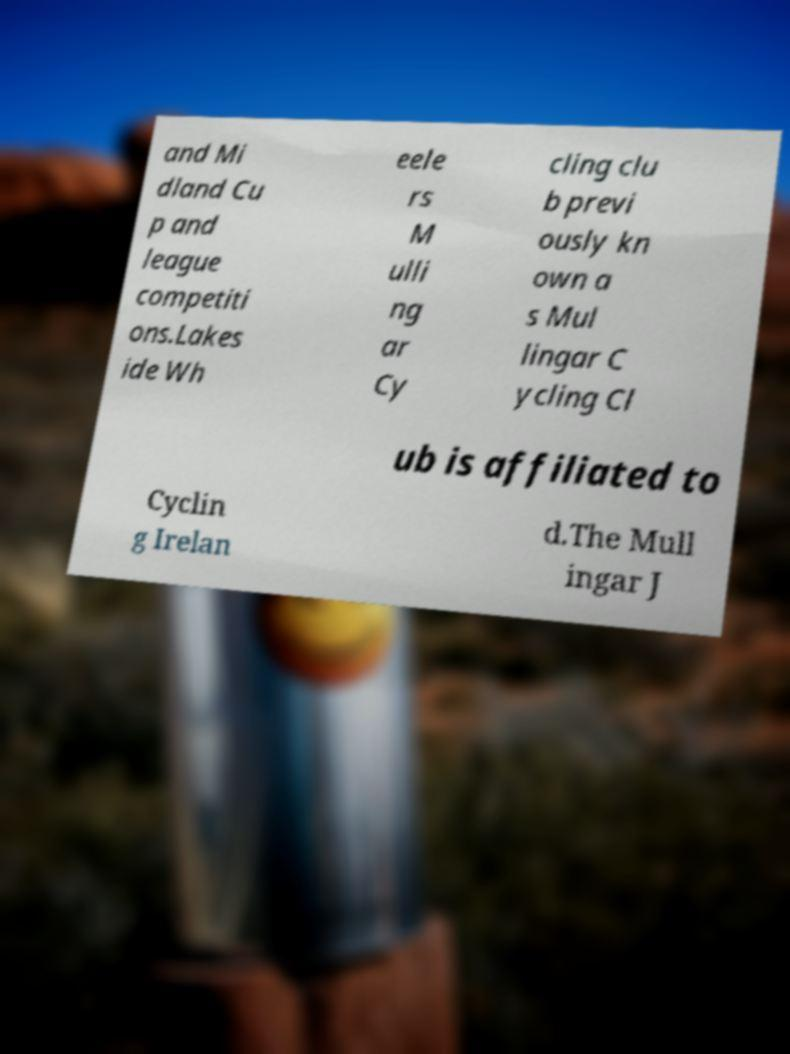What messages or text are displayed in this image? I need them in a readable, typed format. and Mi dland Cu p and league competiti ons.Lakes ide Wh eele rs M ulli ng ar Cy cling clu b previ ously kn own a s Mul lingar C ycling Cl ub is affiliated to Cyclin g Irelan d.The Mull ingar J 